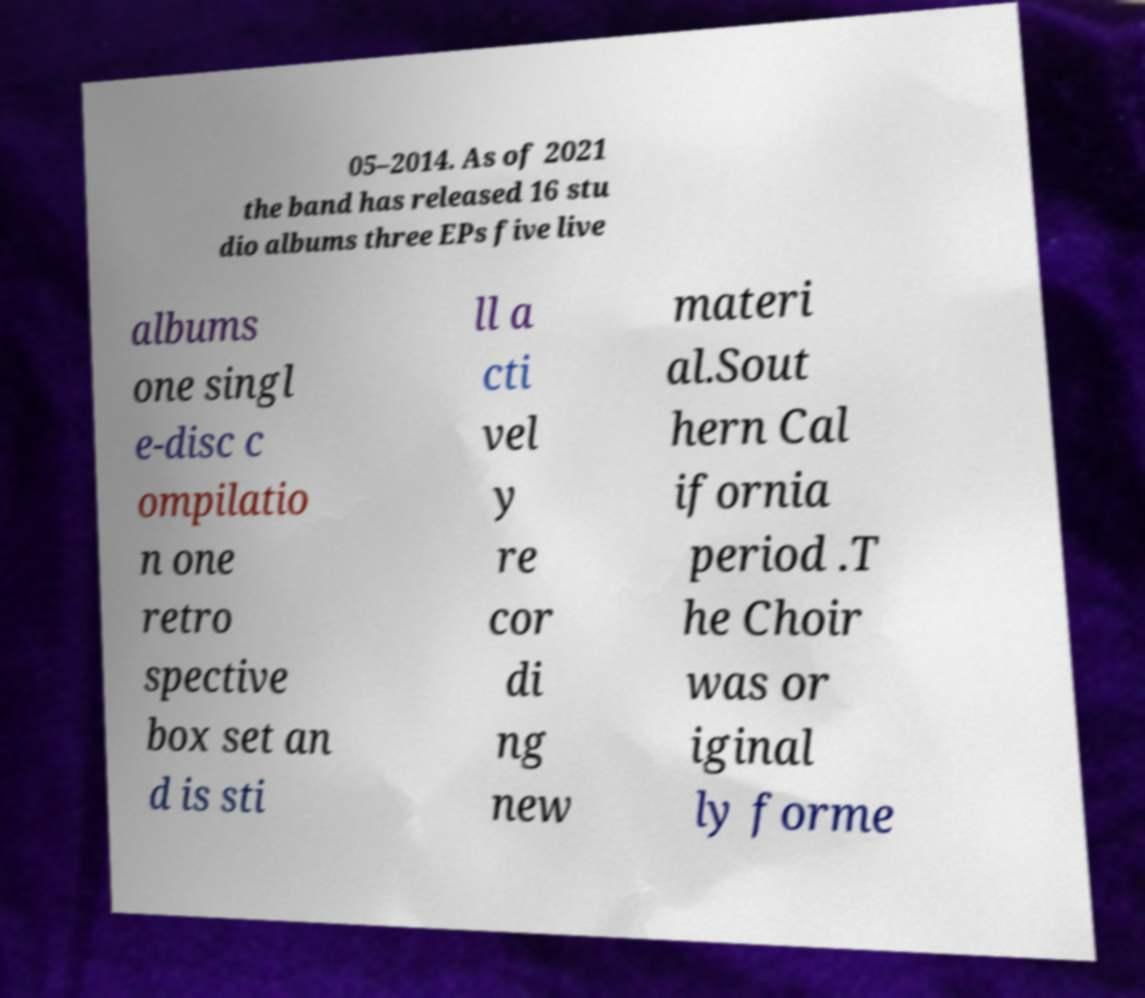Can you read and provide the text displayed in the image?This photo seems to have some interesting text. Can you extract and type it out for me? 05–2014. As of 2021 the band has released 16 stu dio albums three EPs five live albums one singl e-disc c ompilatio n one retro spective box set an d is sti ll a cti vel y re cor di ng new materi al.Sout hern Cal ifornia period .T he Choir was or iginal ly forme 